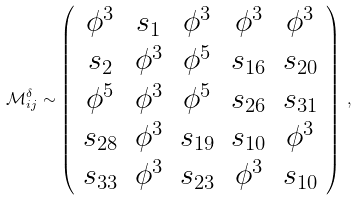<formula> <loc_0><loc_0><loc_500><loc_500>\mathcal { M } ^ { \delta } _ { i j } \sim \left ( \begin{array} { c c c c c } \phi ^ { 3 } & s _ { 1 } & \phi ^ { 3 } & \phi ^ { 3 } & \phi ^ { 3 } \\ s _ { 2 } & \phi ^ { 3 } & \phi ^ { 5 } & s _ { 1 6 } & s _ { 2 0 } \\ \phi ^ { 5 } & \phi ^ { 3 } & \phi ^ { 5 } & s _ { 2 6 } & s _ { 3 1 } \\ s _ { 2 8 } & \phi ^ { 3 } & s _ { 1 9 } & s _ { 1 0 } & \phi ^ { 3 } \\ s _ { 3 3 } & \phi ^ { 3 } & s _ { 2 3 } & \phi ^ { 3 } & s _ { 1 0 } \\ \end{array} \right ) \, ,</formula> 